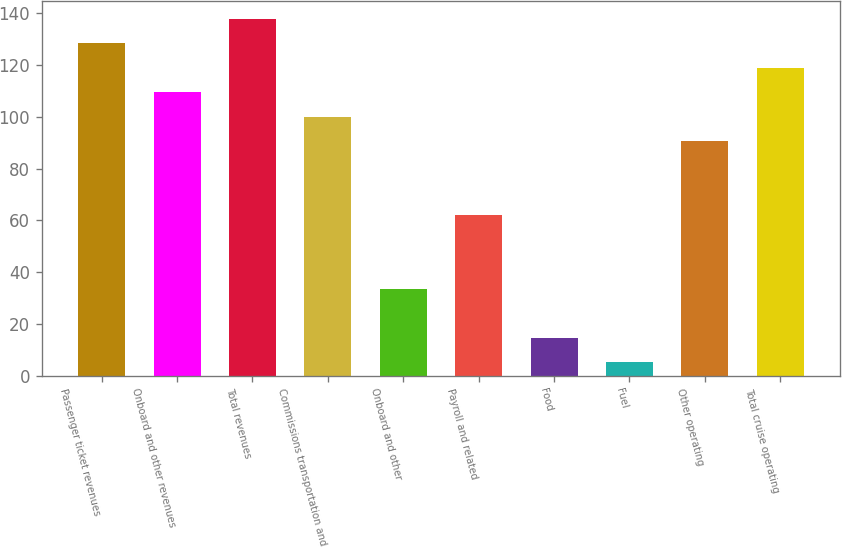Convert chart. <chart><loc_0><loc_0><loc_500><loc_500><bar_chart><fcel>Passenger ticket revenues<fcel>Onboard and other revenues<fcel>Total revenues<fcel>Commissions transportation and<fcel>Onboard and other<fcel>Payroll and related<fcel>Food<fcel>Fuel<fcel>Other operating<fcel>Total cruise operating<nl><fcel>128.44<fcel>109.48<fcel>137.92<fcel>100<fcel>33.64<fcel>62.08<fcel>14.68<fcel>5.2<fcel>90.52<fcel>118.96<nl></chart> 